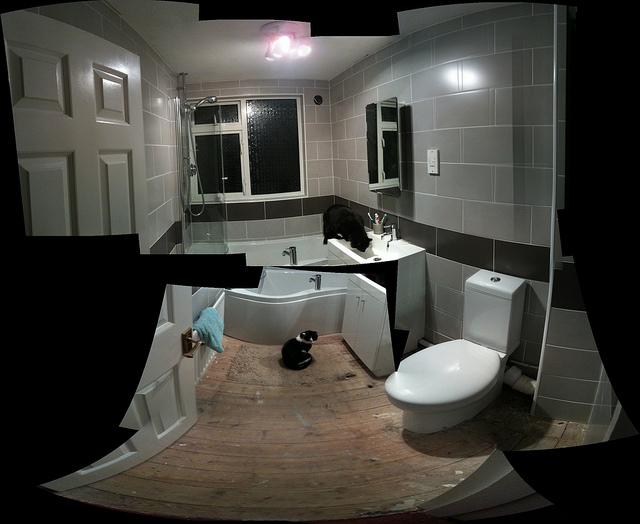What is the color of the toilet?
Short answer required. White. Is the picture framed?
Keep it brief. No. What color is the floor?
Keep it brief. Brown. What is the cat sitting on?
Give a very brief answer. Floor. 